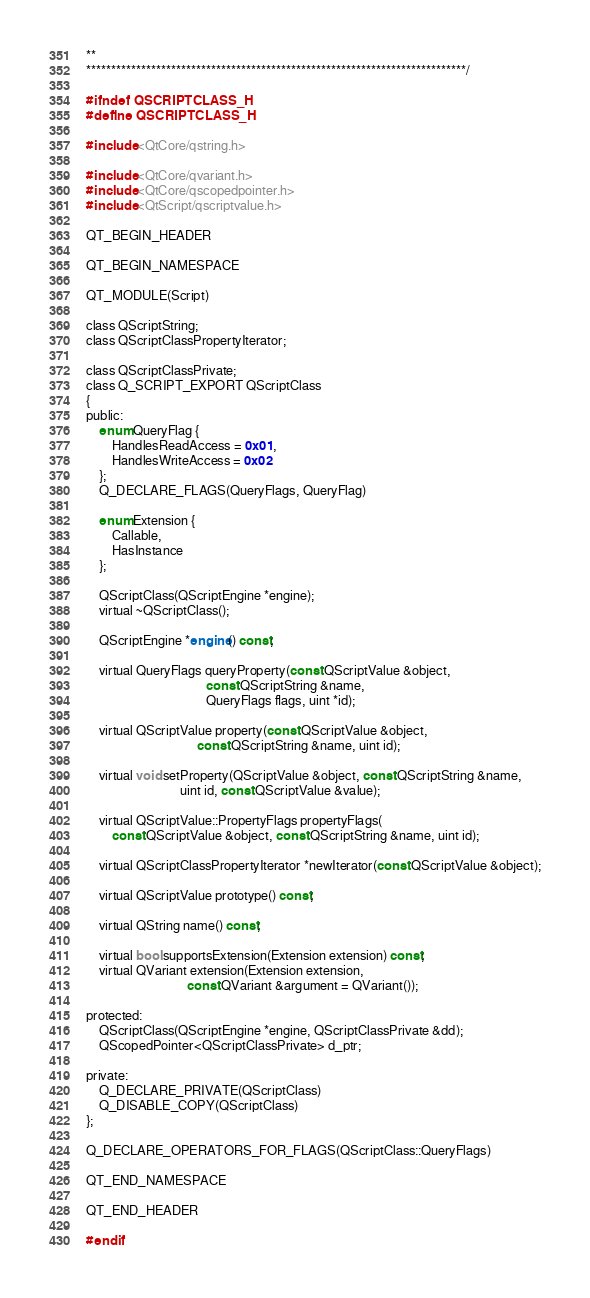Convert code to text. <code><loc_0><loc_0><loc_500><loc_500><_C_>**
****************************************************************************/

#ifndef QSCRIPTCLASS_H
#define QSCRIPTCLASS_H

#include <QtCore/qstring.h>

#include <QtCore/qvariant.h>
#include <QtCore/qscopedpointer.h>
#include <QtScript/qscriptvalue.h>

QT_BEGIN_HEADER

QT_BEGIN_NAMESPACE

QT_MODULE(Script)

class QScriptString;
class QScriptClassPropertyIterator;

class QScriptClassPrivate;
class Q_SCRIPT_EXPORT QScriptClass
{
public:
    enum QueryFlag {
        HandlesReadAccess = 0x01,
        HandlesWriteAccess = 0x02
    };
    Q_DECLARE_FLAGS(QueryFlags, QueryFlag)

    enum Extension {
        Callable,
        HasInstance
    };

    QScriptClass(QScriptEngine *engine);
    virtual ~QScriptClass();

    QScriptEngine *engine() const;

    virtual QueryFlags queryProperty(const QScriptValue &object,
                                     const QScriptString &name,
                                     QueryFlags flags, uint *id);

    virtual QScriptValue property(const QScriptValue &object,
                                  const QScriptString &name, uint id);

    virtual void setProperty(QScriptValue &object, const QScriptString &name,
                             uint id, const QScriptValue &value);

    virtual QScriptValue::PropertyFlags propertyFlags(
        const QScriptValue &object, const QScriptString &name, uint id);

    virtual QScriptClassPropertyIterator *newIterator(const QScriptValue &object);

    virtual QScriptValue prototype() const;

    virtual QString name() const;

    virtual bool supportsExtension(Extension extension) const;
    virtual QVariant extension(Extension extension,
                               const QVariant &argument = QVariant());

protected:
    QScriptClass(QScriptEngine *engine, QScriptClassPrivate &dd);
    QScopedPointer<QScriptClassPrivate> d_ptr;

private:
    Q_DECLARE_PRIVATE(QScriptClass)
    Q_DISABLE_COPY(QScriptClass)
};

Q_DECLARE_OPERATORS_FOR_FLAGS(QScriptClass::QueryFlags)

QT_END_NAMESPACE

QT_END_HEADER

#endif
</code> 